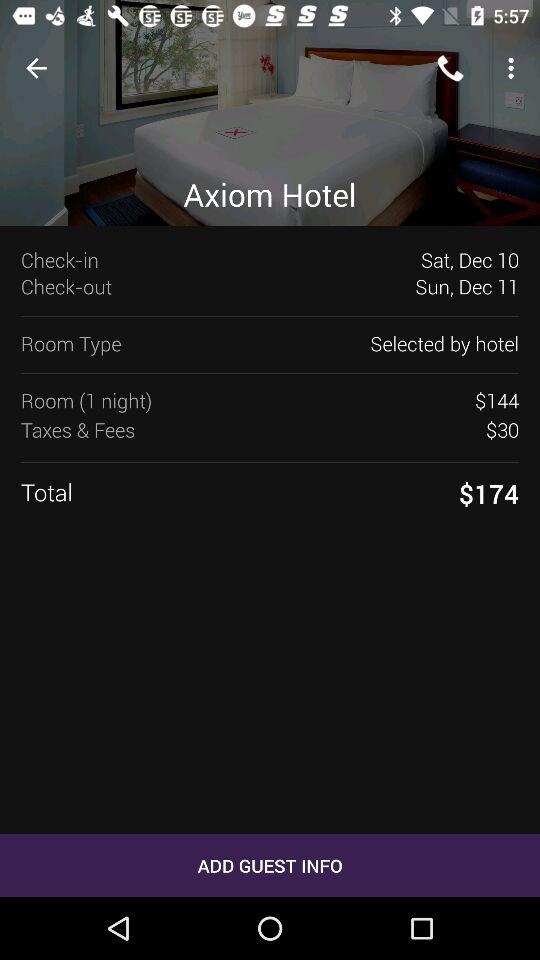What is the check-out date? The check-out date is Sunday, December 11. 